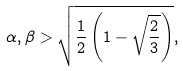Convert formula to latex. <formula><loc_0><loc_0><loc_500><loc_500>\alpha , \beta > \sqrt { \frac { 1 } { 2 } \left ( 1 - \sqrt { \frac { 2 } { 3 } } \right ) } ,</formula> 